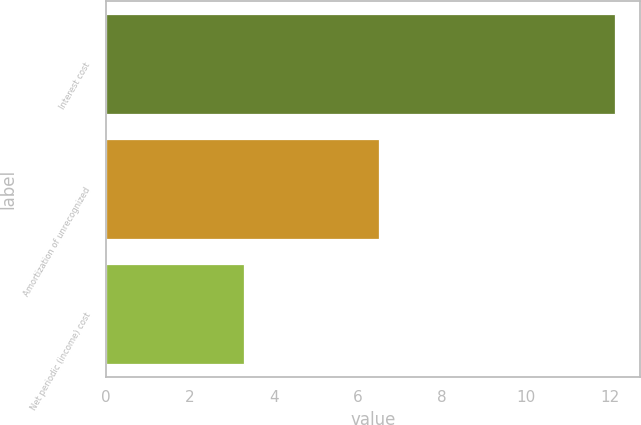Convert chart. <chart><loc_0><loc_0><loc_500><loc_500><bar_chart><fcel>Interest cost<fcel>Amortization of unrecognized<fcel>Net periodic (income) cost<nl><fcel>12.1<fcel>6.5<fcel>3.3<nl></chart> 